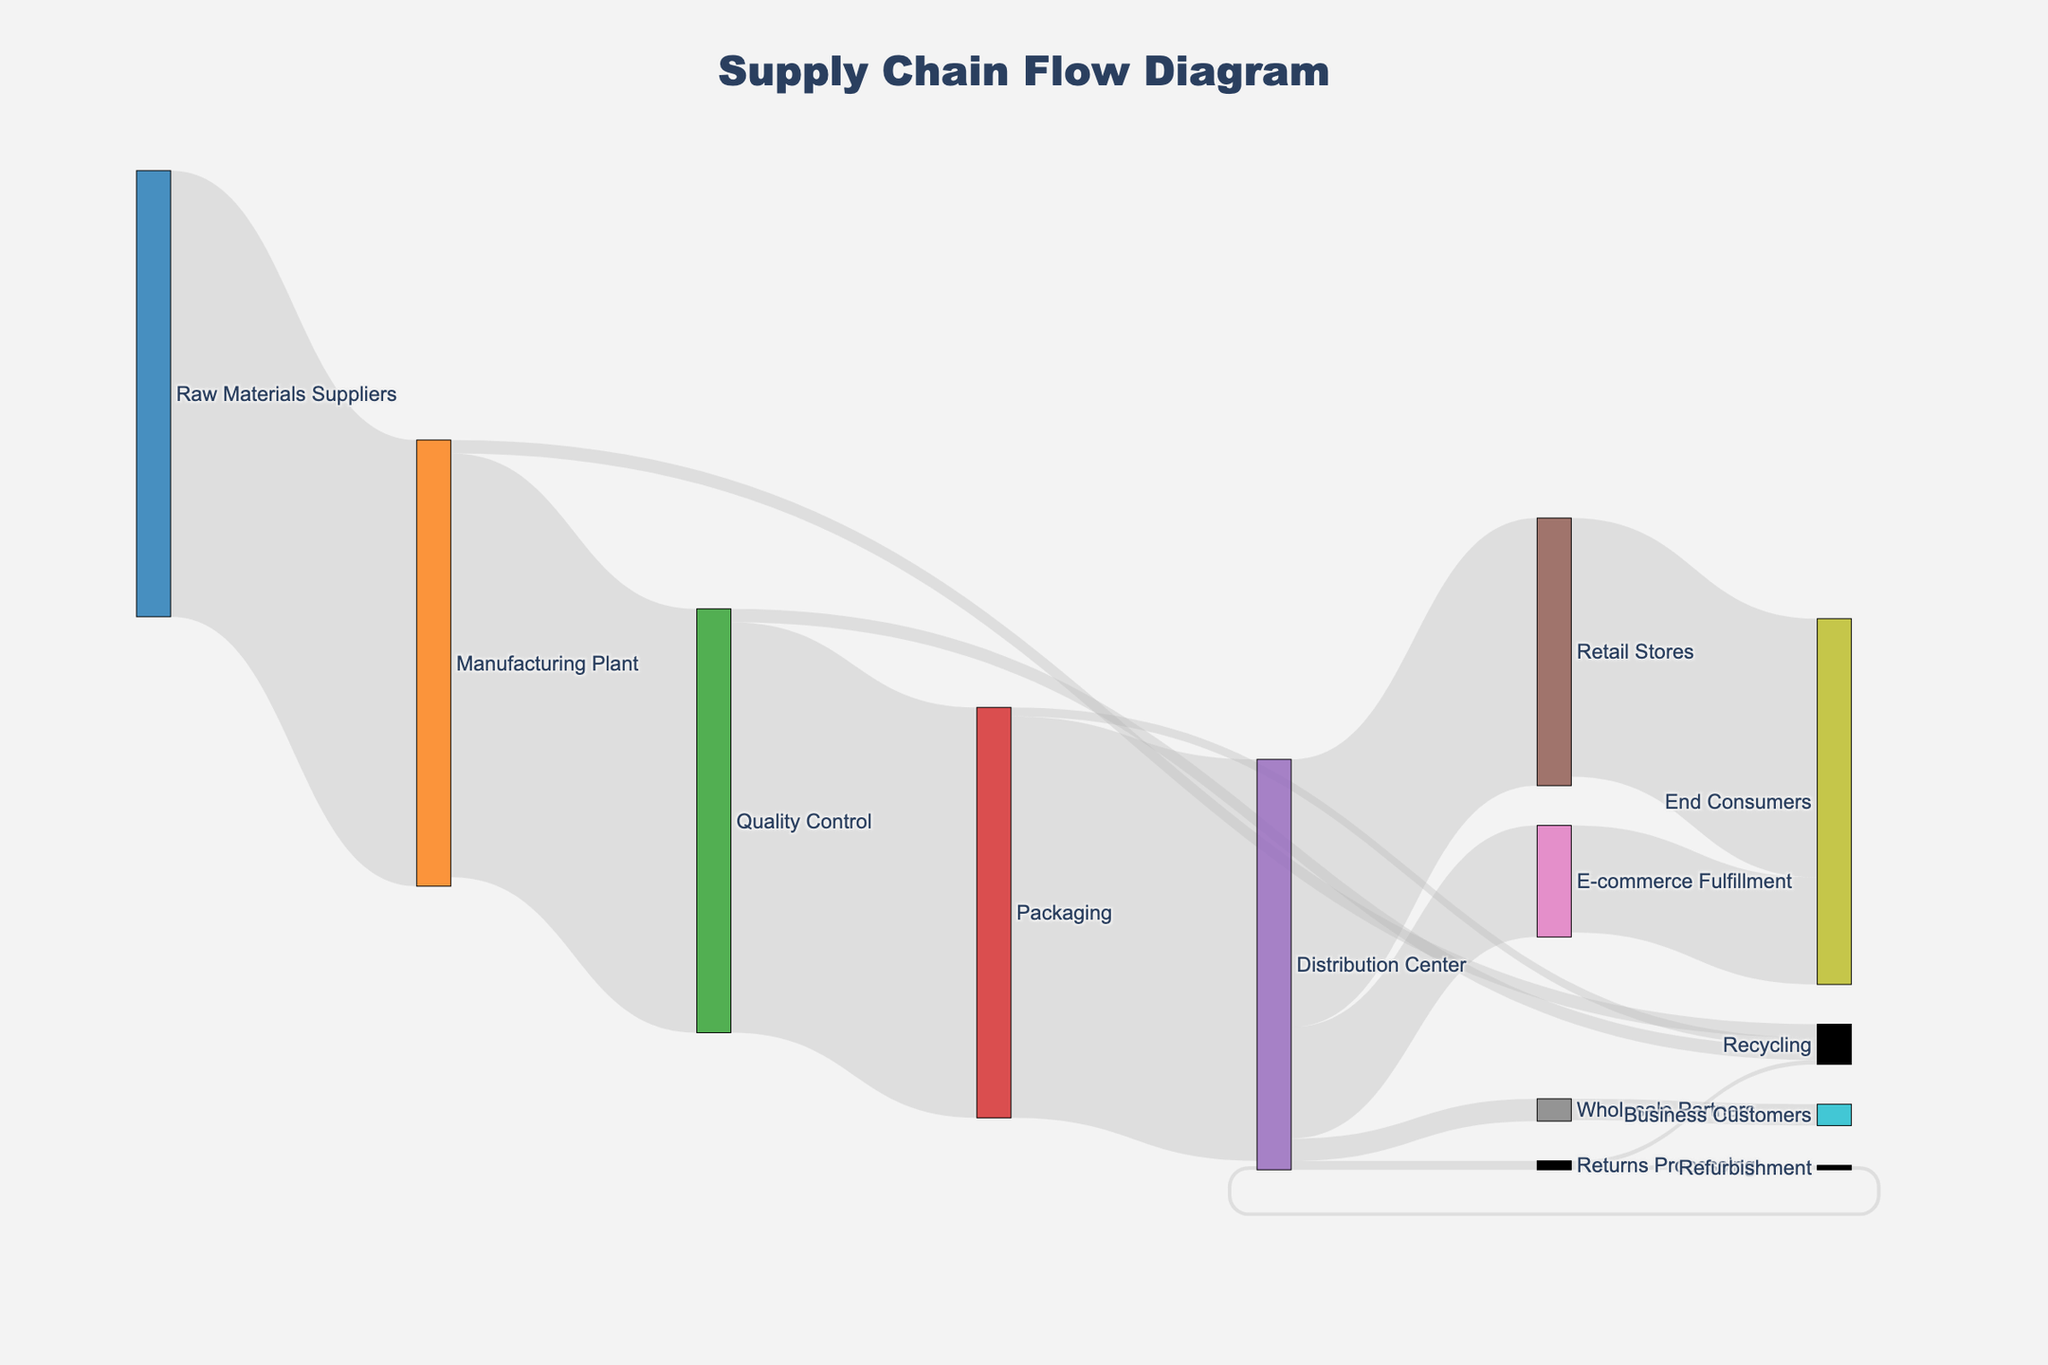what's the highest value link in the Sankey diagram? The largest value link represents the flow from Raw Materials Suppliers to Manufacturing Plant, which is 1000 units.
Answer: 1000 How many units go to Retail Stores from the Distribution Center? According to the Sankey diagram, 600 units are directed from the Distribution Center to Retail Stores.
Answer: 600 Which stage has the highest amount of material loss? From the input data, the difference between Raw Materials Suppliers and Manufacturing Plant is 50 units, the difference between Manufacturing Plant and Quality Control is also 50 units, and so on. The stage with the most loss seems to be the transition from Raw Materials Suppliers to Manufacturing Plant with a loss of 50 units.
Answer: Raw Materials Suppliers to Manufacturing Plant How many units are supplied to E-commerce Fulfillment from Distribution Center? The Sankey diagram shows that 250 units flow from the Distribution Center to E-commerce Fulfillment.
Answer: 250 What percentage of materials are recycled after Quality Control? At Quality Control, 950 units are checked, and 30 units are sent to Recycling. The recycling rate is (30/950) * 100 = 3.16%.
Answer: 3.16% Compare the units of material that go to Recycling from Manufacturing Plant and Quality Control. Which is greater? Both Manufacturing Plant and Quality Control direct 30 units to Recycling. Thus, they are equal.
Answer: Equal What is the total number of units that the Distribution Center handles including returns? The units flowing into Distribution Center are from Packaging (900). Returns Processing also sends 10 units back to Distribution Center. So, the total is 900 + 10 = 910 units.
Answer: 910 How many units reach the end consumers through e-commerce and retail combined? The units reaching End Consumers from Retail Stores are 580, and from E-commerce Fulfillment, it's 240. Combined, they sum up to 580 + 240 = 820 units.
Answer: 820 